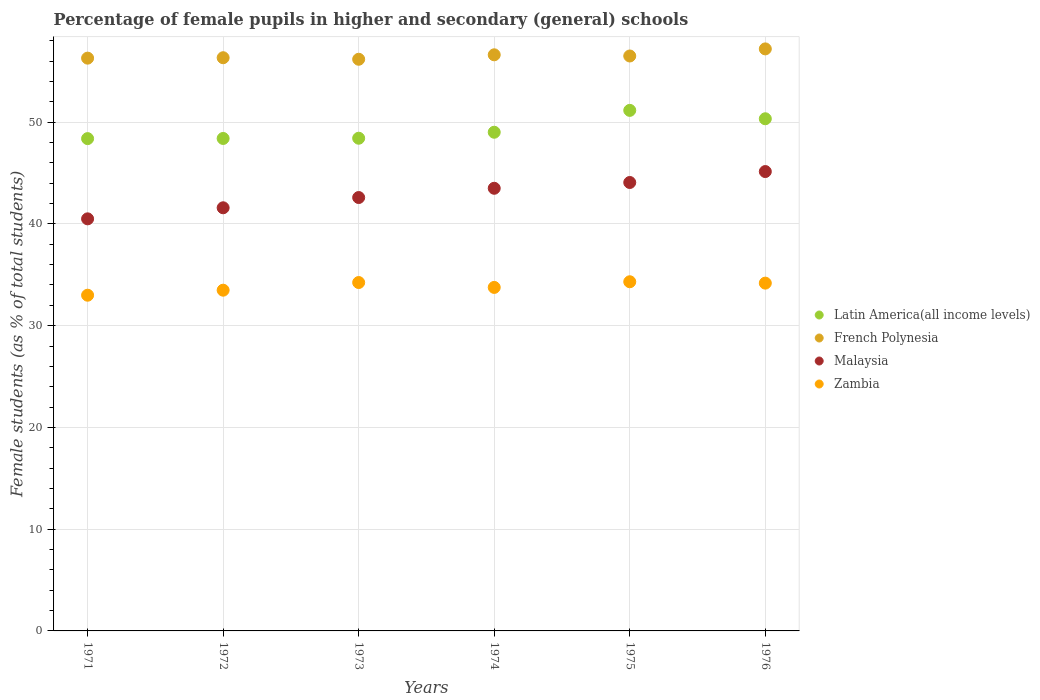Is the number of dotlines equal to the number of legend labels?
Ensure brevity in your answer.  Yes. What is the percentage of female pupils in higher and secondary schools in French Polynesia in 1971?
Your response must be concise. 56.29. Across all years, what is the maximum percentage of female pupils in higher and secondary schools in French Polynesia?
Your response must be concise. 57.2. Across all years, what is the minimum percentage of female pupils in higher and secondary schools in French Polynesia?
Offer a very short reply. 56.18. In which year was the percentage of female pupils in higher and secondary schools in Latin America(all income levels) maximum?
Offer a very short reply. 1975. What is the total percentage of female pupils in higher and secondary schools in French Polynesia in the graph?
Your answer should be compact. 339.11. What is the difference between the percentage of female pupils in higher and secondary schools in Latin America(all income levels) in 1975 and that in 1976?
Give a very brief answer. 0.82. What is the difference between the percentage of female pupils in higher and secondary schools in French Polynesia in 1975 and the percentage of female pupils in higher and secondary schools in Latin America(all income levels) in 1974?
Offer a terse response. 7.49. What is the average percentage of female pupils in higher and secondary schools in French Polynesia per year?
Give a very brief answer. 56.52. In the year 1974, what is the difference between the percentage of female pupils in higher and secondary schools in French Polynesia and percentage of female pupils in higher and secondary schools in Zambia?
Provide a short and direct response. 22.86. What is the ratio of the percentage of female pupils in higher and secondary schools in French Polynesia in 1972 to that in 1973?
Ensure brevity in your answer.  1. Is the percentage of female pupils in higher and secondary schools in Latin America(all income levels) in 1975 less than that in 1976?
Your answer should be very brief. No. What is the difference between the highest and the second highest percentage of female pupils in higher and secondary schools in Zambia?
Offer a terse response. 0.08. What is the difference between the highest and the lowest percentage of female pupils in higher and secondary schools in French Polynesia?
Offer a very short reply. 1.02. In how many years, is the percentage of female pupils in higher and secondary schools in Zambia greater than the average percentage of female pupils in higher and secondary schools in Zambia taken over all years?
Your response must be concise. 3. Is the sum of the percentage of female pupils in higher and secondary schools in Latin America(all income levels) in 1971 and 1975 greater than the maximum percentage of female pupils in higher and secondary schools in Zambia across all years?
Keep it short and to the point. Yes. Is the percentage of female pupils in higher and secondary schools in French Polynesia strictly greater than the percentage of female pupils in higher and secondary schools in Malaysia over the years?
Offer a very short reply. Yes. Is the percentage of female pupils in higher and secondary schools in Latin America(all income levels) strictly less than the percentage of female pupils in higher and secondary schools in Malaysia over the years?
Offer a terse response. No. How many years are there in the graph?
Provide a succinct answer. 6. What is the difference between two consecutive major ticks on the Y-axis?
Give a very brief answer. 10. Does the graph contain any zero values?
Your answer should be compact. No. Does the graph contain grids?
Provide a short and direct response. Yes. Where does the legend appear in the graph?
Your answer should be very brief. Center right. How are the legend labels stacked?
Make the answer very short. Vertical. What is the title of the graph?
Your response must be concise. Percentage of female pupils in higher and secondary (general) schools. What is the label or title of the Y-axis?
Offer a terse response. Female students (as % of total students). What is the Female students (as % of total students) in Latin America(all income levels) in 1971?
Make the answer very short. 48.38. What is the Female students (as % of total students) of French Polynesia in 1971?
Provide a short and direct response. 56.29. What is the Female students (as % of total students) in Malaysia in 1971?
Ensure brevity in your answer.  40.5. What is the Female students (as % of total students) of Zambia in 1971?
Your response must be concise. 32.99. What is the Female students (as % of total students) of Latin America(all income levels) in 1972?
Make the answer very short. 48.4. What is the Female students (as % of total students) in French Polynesia in 1972?
Offer a very short reply. 56.33. What is the Female students (as % of total students) in Malaysia in 1972?
Provide a short and direct response. 41.58. What is the Female students (as % of total students) of Zambia in 1972?
Your response must be concise. 33.48. What is the Female students (as % of total students) of Latin America(all income levels) in 1973?
Make the answer very short. 48.42. What is the Female students (as % of total students) of French Polynesia in 1973?
Give a very brief answer. 56.18. What is the Female students (as % of total students) in Malaysia in 1973?
Offer a terse response. 42.59. What is the Female students (as % of total students) of Zambia in 1973?
Keep it short and to the point. 34.24. What is the Female students (as % of total students) in Latin America(all income levels) in 1974?
Ensure brevity in your answer.  49.01. What is the Female students (as % of total students) of French Polynesia in 1974?
Provide a short and direct response. 56.62. What is the Female students (as % of total students) of Malaysia in 1974?
Provide a succinct answer. 43.5. What is the Female students (as % of total students) in Zambia in 1974?
Keep it short and to the point. 33.76. What is the Female students (as % of total students) of Latin America(all income levels) in 1975?
Provide a succinct answer. 51.16. What is the Female students (as % of total students) in French Polynesia in 1975?
Provide a short and direct response. 56.5. What is the Female students (as % of total students) in Malaysia in 1975?
Provide a succinct answer. 44.07. What is the Female students (as % of total students) in Zambia in 1975?
Keep it short and to the point. 34.31. What is the Female students (as % of total students) of Latin America(all income levels) in 1976?
Provide a short and direct response. 50.33. What is the Female students (as % of total students) in French Polynesia in 1976?
Provide a short and direct response. 57.2. What is the Female students (as % of total students) of Malaysia in 1976?
Provide a succinct answer. 45.14. What is the Female students (as % of total students) of Zambia in 1976?
Offer a very short reply. 34.18. Across all years, what is the maximum Female students (as % of total students) in Latin America(all income levels)?
Provide a succinct answer. 51.16. Across all years, what is the maximum Female students (as % of total students) of French Polynesia?
Your answer should be very brief. 57.2. Across all years, what is the maximum Female students (as % of total students) of Malaysia?
Keep it short and to the point. 45.14. Across all years, what is the maximum Female students (as % of total students) of Zambia?
Ensure brevity in your answer.  34.31. Across all years, what is the minimum Female students (as % of total students) in Latin America(all income levels)?
Your answer should be very brief. 48.38. Across all years, what is the minimum Female students (as % of total students) of French Polynesia?
Provide a succinct answer. 56.18. Across all years, what is the minimum Female students (as % of total students) of Malaysia?
Offer a very short reply. 40.5. Across all years, what is the minimum Female students (as % of total students) of Zambia?
Your answer should be very brief. 32.99. What is the total Female students (as % of total students) in Latin America(all income levels) in the graph?
Keep it short and to the point. 295.69. What is the total Female students (as % of total students) in French Polynesia in the graph?
Offer a very short reply. 339.11. What is the total Female students (as % of total students) of Malaysia in the graph?
Keep it short and to the point. 257.38. What is the total Female students (as % of total students) of Zambia in the graph?
Your answer should be very brief. 202.96. What is the difference between the Female students (as % of total students) in Latin America(all income levels) in 1971 and that in 1972?
Offer a very short reply. -0.01. What is the difference between the Female students (as % of total students) of French Polynesia in 1971 and that in 1972?
Keep it short and to the point. -0.04. What is the difference between the Female students (as % of total students) in Malaysia in 1971 and that in 1972?
Offer a very short reply. -1.09. What is the difference between the Female students (as % of total students) of Zambia in 1971 and that in 1972?
Make the answer very short. -0.49. What is the difference between the Female students (as % of total students) in Latin America(all income levels) in 1971 and that in 1973?
Your answer should be very brief. -0.04. What is the difference between the Female students (as % of total students) of French Polynesia in 1971 and that in 1973?
Provide a short and direct response. 0.11. What is the difference between the Female students (as % of total students) in Malaysia in 1971 and that in 1973?
Keep it short and to the point. -2.09. What is the difference between the Female students (as % of total students) in Zambia in 1971 and that in 1973?
Offer a very short reply. -1.25. What is the difference between the Female students (as % of total students) in Latin America(all income levels) in 1971 and that in 1974?
Provide a short and direct response. -0.63. What is the difference between the Female students (as % of total students) of French Polynesia in 1971 and that in 1974?
Provide a short and direct response. -0.33. What is the difference between the Female students (as % of total students) in Malaysia in 1971 and that in 1974?
Your answer should be very brief. -3. What is the difference between the Female students (as % of total students) of Zambia in 1971 and that in 1974?
Keep it short and to the point. -0.77. What is the difference between the Female students (as % of total students) in Latin America(all income levels) in 1971 and that in 1975?
Give a very brief answer. -2.77. What is the difference between the Female students (as % of total students) of French Polynesia in 1971 and that in 1975?
Give a very brief answer. -0.21. What is the difference between the Female students (as % of total students) in Malaysia in 1971 and that in 1975?
Your answer should be compact. -3.57. What is the difference between the Female students (as % of total students) of Zambia in 1971 and that in 1975?
Make the answer very short. -1.32. What is the difference between the Female students (as % of total students) of Latin America(all income levels) in 1971 and that in 1976?
Offer a terse response. -1.95. What is the difference between the Female students (as % of total students) in French Polynesia in 1971 and that in 1976?
Provide a succinct answer. -0.91. What is the difference between the Female students (as % of total students) in Malaysia in 1971 and that in 1976?
Ensure brevity in your answer.  -4.65. What is the difference between the Female students (as % of total students) of Zambia in 1971 and that in 1976?
Your answer should be very brief. -1.19. What is the difference between the Female students (as % of total students) in Latin America(all income levels) in 1972 and that in 1973?
Make the answer very short. -0.02. What is the difference between the Female students (as % of total students) in French Polynesia in 1972 and that in 1973?
Your answer should be very brief. 0.15. What is the difference between the Female students (as % of total students) in Malaysia in 1972 and that in 1973?
Give a very brief answer. -1.01. What is the difference between the Female students (as % of total students) in Zambia in 1972 and that in 1973?
Provide a succinct answer. -0.75. What is the difference between the Female students (as % of total students) of Latin America(all income levels) in 1972 and that in 1974?
Offer a terse response. -0.61. What is the difference between the Female students (as % of total students) in French Polynesia in 1972 and that in 1974?
Your response must be concise. -0.29. What is the difference between the Female students (as % of total students) in Malaysia in 1972 and that in 1974?
Provide a succinct answer. -1.92. What is the difference between the Female students (as % of total students) of Zambia in 1972 and that in 1974?
Provide a short and direct response. -0.27. What is the difference between the Female students (as % of total students) of Latin America(all income levels) in 1972 and that in 1975?
Make the answer very short. -2.76. What is the difference between the Female students (as % of total students) of French Polynesia in 1972 and that in 1975?
Give a very brief answer. -0.17. What is the difference between the Female students (as % of total students) in Malaysia in 1972 and that in 1975?
Your answer should be very brief. -2.49. What is the difference between the Female students (as % of total students) in Zambia in 1972 and that in 1975?
Give a very brief answer. -0.83. What is the difference between the Female students (as % of total students) of Latin America(all income levels) in 1972 and that in 1976?
Your answer should be very brief. -1.94. What is the difference between the Female students (as % of total students) of French Polynesia in 1972 and that in 1976?
Give a very brief answer. -0.87. What is the difference between the Female students (as % of total students) in Malaysia in 1972 and that in 1976?
Keep it short and to the point. -3.56. What is the difference between the Female students (as % of total students) of Zambia in 1972 and that in 1976?
Offer a very short reply. -0.69. What is the difference between the Female students (as % of total students) of Latin America(all income levels) in 1973 and that in 1974?
Provide a short and direct response. -0.59. What is the difference between the Female students (as % of total students) of French Polynesia in 1973 and that in 1974?
Your answer should be compact. -0.44. What is the difference between the Female students (as % of total students) of Malaysia in 1973 and that in 1974?
Make the answer very short. -0.91. What is the difference between the Female students (as % of total students) in Zambia in 1973 and that in 1974?
Make the answer very short. 0.48. What is the difference between the Female students (as % of total students) in Latin America(all income levels) in 1973 and that in 1975?
Ensure brevity in your answer.  -2.74. What is the difference between the Female students (as % of total students) in French Polynesia in 1973 and that in 1975?
Give a very brief answer. -0.32. What is the difference between the Female students (as % of total students) of Malaysia in 1973 and that in 1975?
Make the answer very short. -1.48. What is the difference between the Female students (as % of total students) of Zambia in 1973 and that in 1975?
Make the answer very short. -0.08. What is the difference between the Female students (as % of total students) of Latin America(all income levels) in 1973 and that in 1976?
Provide a short and direct response. -1.91. What is the difference between the Female students (as % of total students) of French Polynesia in 1973 and that in 1976?
Your answer should be very brief. -1.02. What is the difference between the Female students (as % of total students) in Malaysia in 1973 and that in 1976?
Keep it short and to the point. -2.55. What is the difference between the Female students (as % of total students) of Zambia in 1973 and that in 1976?
Your answer should be very brief. 0.06. What is the difference between the Female students (as % of total students) of Latin America(all income levels) in 1974 and that in 1975?
Provide a succinct answer. -2.15. What is the difference between the Female students (as % of total students) of French Polynesia in 1974 and that in 1975?
Keep it short and to the point. 0.12. What is the difference between the Female students (as % of total students) of Malaysia in 1974 and that in 1975?
Provide a succinct answer. -0.57. What is the difference between the Female students (as % of total students) of Zambia in 1974 and that in 1975?
Keep it short and to the point. -0.56. What is the difference between the Female students (as % of total students) of Latin America(all income levels) in 1974 and that in 1976?
Make the answer very short. -1.32. What is the difference between the Female students (as % of total students) of French Polynesia in 1974 and that in 1976?
Your answer should be very brief. -0.58. What is the difference between the Female students (as % of total students) of Malaysia in 1974 and that in 1976?
Offer a terse response. -1.64. What is the difference between the Female students (as % of total students) in Zambia in 1974 and that in 1976?
Ensure brevity in your answer.  -0.42. What is the difference between the Female students (as % of total students) of Latin America(all income levels) in 1975 and that in 1976?
Give a very brief answer. 0.82. What is the difference between the Female students (as % of total students) of French Polynesia in 1975 and that in 1976?
Offer a very short reply. -0.7. What is the difference between the Female students (as % of total students) of Malaysia in 1975 and that in 1976?
Ensure brevity in your answer.  -1.07. What is the difference between the Female students (as % of total students) of Zambia in 1975 and that in 1976?
Your answer should be very brief. 0.14. What is the difference between the Female students (as % of total students) in Latin America(all income levels) in 1971 and the Female students (as % of total students) in French Polynesia in 1972?
Make the answer very short. -7.95. What is the difference between the Female students (as % of total students) of Latin America(all income levels) in 1971 and the Female students (as % of total students) of Malaysia in 1972?
Keep it short and to the point. 6.8. What is the difference between the Female students (as % of total students) of Latin America(all income levels) in 1971 and the Female students (as % of total students) of Zambia in 1972?
Provide a short and direct response. 14.9. What is the difference between the Female students (as % of total students) of French Polynesia in 1971 and the Female students (as % of total students) of Malaysia in 1972?
Your answer should be very brief. 14.71. What is the difference between the Female students (as % of total students) of French Polynesia in 1971 and the Female students (as % of total students) of Zambia in 1972?
Offer a terse response. 22.8. What is the difference between the Female students (as % of total students) in Malaysia in 1971 and the Female students (as % of total students) in Zambia in 1972?
Give a very brief answer. 7.01. What is the difference between the Female students (as % of total students) in Latin America(all income levels) in 1971 and the Female students (as % of total students) in French Polynesia in 1973?
Ensure brevity in your answer.  -7.8. What is the difference between the Female students (as % of total students) in Latin America(all income levels) in 1971 and the Female students (as % of total students) in Malaysia in 1973?
Offer a very short reply. 5.79. What is the difference between the Female students (as % of total students) in Latin America(all income levels) in 1971 and the Female students (as % of total students) in Zambia in 1973?
Provide a short and direct response. 14.14. What is the difference between the Female students (as % of total students) of French Polynesia in 1971 and the Female students (as % of total students) of Malaysia in 1973?
Offer a very short reply. 13.7. What is the difference between the Female students (as % of total students) of French Polynesia in 1971 and the Female students (as % of total students) of Zambia in 1973?
Your response must be concise. 22.05. What is the difference between the Female students (as % of total students) of Malaysia in 1971 and the Female students (as % of total students) of Zambia in 1973?
Make the answer very short. 6.26. What is the difference between the Female students (as % of total students) in Latin America(all income levels) in 1971 and the Female students (as % of total students) in French Polynesia in 1974?
Provide a succinct answer. -8.24. What is the difference between the Female students (as % of total students) in Latin America(all income levels) in 1971 and the Female students (as % of total students) in Malaysia in 1974?
Keep it short and to the point. 4.88. What is the difference between the Female students (as % of total students) in Latin America(all income levels) in 1971 and the Female students (as % of total students) in Zambia in 1974?
Provide a succinct answer. 14.62. What is the difference between the Female students (as % of total students) in French Polynesia in 1971 and the Female students (as % of total students) in Malaysia in 1974?
Provide a succinct answer. 12.79. What is the difference between the Female students (as % of total students) in French Polynesia in 1971 and the Female students (as % of total students) in Zambia in 1974?
Give a very brief answer. 22.53. What is the difference between the Female students (as % of total students) in Malaysia in 1971 and the Female students (as % of total students) in Zambia in 1974?
Your answer should be very brief. 6.74. What is the difference between the Female students (as % of total students) in Latin America(all income levels) in 1971 and the Female students (as % of total students) in French Polynesia in 1975?
Make the answer very short. -8.12. What is the difference between the Female students (as % of total students) of Latin America(all income levels) in 1971 and the Female students (as % of total students) of Malaysia in 1975?
Your answer should be very brief. 4.31. What is the difference between the Female students (as % of total students) in Latin America(all income levels) in 1971 and the Female students (as % of total students) in Zambia in 1975?
Keep it short and to the point. 14.07. What is the difference between the Female students (as % of total students) of French Polynesia in 1971 and the Female students (as % of total students) of Malaysia in 1975?
Give a very brief answer. 12.22. What is the difference between the Female students (as % of total students) of French Polynesia in 1971 and the Female students (as % of total students) of Zambia in 1975?
Offer a very short reply. 21.97. What is the difference between the Female students (as % of total students) of Malaysia in 1971 and the Female students (as % of total students) of Zambia in 1975?
Provide a short and direct response. 6.18. What is the difference between the Female students (as % of total students) of Latin America(all income levels) in 1971 and the Female students (as % of total students) of French Polynesia in 1976?
Offer a very short reply. -8.82. What is the difference between the Female students (as % of total students) in Latin America(all income levels) in 1971 and the Female students (as % of total students) in Malaysia in 1976?
Offer a very short reply. 3.24. What is the difference between the Female students (as % of total students) in Latin America(all income levels) in 1971 and the Female students (as % of total students) in Zambia in 1976?
Offer a very short reply. 14.2. What is the difference between the Female students (as % of total students) in French Polynesia in 1971 and the Female students (as % of total students) in Malaysia in 1976?
Provide a succinct answer. 11.14. What is the difference between the Female students (as % of total students) of French Polynesia in 1971 and the Female students (as % of total students) of Zambia in 1976?
Offer a very short reply. 22.11. What is the difference between the Female students (as % of total students) of Malaysia in 1971 and the Female students (as % of total students) of Zambia in 1976?
Your answer should be very brief. 6.32. What is the difference between the Female students (as % of total students) in Latin America(all income levels) in 1972 and the Female students (as % of total students) in French Polynesia in 1973?
Provide a succinct answer. -7.78. What is the difference between the Female students (as % of total students) of Latin America(all income levels) in 1972 and the Female students (as % of total students) of Malaysia in 1973?
Offer a very short reply. 5.8. What is the difference between the Female students (as % of total students) in Latin America(all income levels) in 1972 and the Female students (as % of total students) in Zambia in 1973?
Offer a terse response. 14.16. What is the difference between the Female students (as % of total students) in French Polynesia in 1972 and the Female students (as % of total students) in Malaysia in 1973?
Your response must be concise. 13.74. What is the difference between the Female students (as % of total students) in French Polynesia in 1972 and the Female students (as % of total students) in Zambia in 1973?
Give a very brief answer. 22.09. What is the difference between the Female students (as % of total students) in Malaysia in 1972 and the Female students (as % of total students) in Zambia in 1973?
Provide a short and direct response. 7.35. What is the difference between the Female students (as % of total students) in Latin America(all income levels) in 1972 and the Female students (as % of total students) in French Polynesia in 1974?
Offer a very short reply. -8.22. What is the difference between the Female students (as % of total students) of Latin America(all income levels) in 1972 and the Female students (as % of total students) of Malaysia in 1974?
Provide a short and direct response. 4.9. What is the difference between the Female students (as % of total students) of Latin America(all income levels) in 1972 and the Female students (as % of total students) of Zambia in 1974?
Your answer should be compact. 14.64. What is the difference between the Female students (as % of total students) of French Polynesia in 1972 and the Female students (as % of total students) of Malaysia in 1974?
Offer a terse response. 12.83. What is the difference between the Female students (as % of total students) of French Polynesia in 1972 and the Female students (as % of total students) of Zambia in 1974?
Give a very brief answer. 22.57. What is the difference between the Female students (as % of total students) of Malaysia in 1972 and the Female students (as % of total students) of Zambia in 1974?
Keep it short and to the point. 7.83. What is the difference between the Female students (as % of total students) of Latin America(all income levels) in 1972 and the Female students (as % of total students) of French Polynesia in 1975?
Provide a succinct answer. -8.11. What is the difference between the Female students (as % of total students) of Latin America(all income levels) in 1972 and the Female students (as % of total students) of Malaysia in 1975?
Offer a very short reply. 4.33. What is the difference between the Female students (as % of total students) in Latin America(all income levels) in 1972 and the Female students (as % of total students) in Zambia in 1975?
Your answer should be very brief. 14.08. What is the difference between the Female students (as % of total students) in French Polynesia in 1972 and the Female students (as % of total students) in Malaysia in 1975?
Give a very brief answer. 12.26. What is the difference between the Female students (as % of total students) of French Polynesia in 1972 and the Female students (as % of total students) of Zambia in 1975?
Your answer should be compact. 22.02. What is the difference between the Female students (as % of total students) of Malaysia in 1972 and the Female students (as % of total students) of Zambia in 1975?
Provide a short and direct response. 7.27. What is the difference between the Female students (as % of total students) in Latin America(all income levels) in 1972 and the Female students (as % of total students) in French Polynesia in 1976?
Keep it short and to the point. -8.8. What is the difference between the Female students (as % of total students) of Latin America(all income levels) in 1972 and the Female students (as % of total students) of Malaysia in 1976?
Offer a very short reply. 3.25. What is the difference between the Female students (as % of total students) of Latin America(all income levels) in 1972 and the Female students (as % of total students) of Zambia in 1976?
Your answer should be very brief. 14.22. What is the difference between the Female students (as % of total students) of French Polynesia in 1972 and the Female students (as % of total students) of Malaysia in 1976?
Make the answer very short. 11.19. What is the difference between the Female students (as % of total students) of French Polynesia in 1972 and the Female students (as % of total students) of Zambia in 1976?
Ensure brevity in your answer.  22.15. What is the difference between the Female students (as % of total students) of Malaysia in 1972 and the Female students (as % of total students) of Zambia in 1976?
Provide a succinct answer. 7.41. What is the difference between the Female students (as % of total students) in Latin America(all income levels) in 1973 and the Female students (as % of total students) in French Polynesia in 1974?
Your answer should be very brief. -8.2. What is the difference between the Female students (as % of total students) of Latin America(all income levels) in 1973 and the Female students (as % of total students) of Malaysia in 1974?
Provide a succinct answer. 4.92. What is the difference between the Female students (as % of total students) in Latin America(all income levels) in 1973 and the Female students (as % of total students) in Zambia in 1974?
Ensure brevity in your answer.  14.66. What is the difference between the Female students (as % of total students) of French Polynesia in 1973 and the Female students (as % of total students) of Malaysia in 1974?
Your answer should be compact. 12.68. What is the difference between the Female students (as % of total students) in French Polynesia in 1973 and the Female students (as % of total students) in Zambia in 1974?
Offer a terse response. 22.42. What is the difference between the Female students (as % of total students) of Malaysia in 1973 and the Female students (as % of total students) of Zambia in 1974?
Keep it short and to the point. 8.83. What is the difference between the Female students (as % of total students) in Latin America(all income levels) in 1973 and the Female students (as % of total students) in French Polynesia in 1975?
Offer a terse response. -8.08. What is the difference between the Female students (as % of total students) of Latin America(all income levels) in 1973 and the Female students (as % of total students) of Malaysia in 1975?
Your answer should be very brief. 4.35. What is the difference between the Female students (as % of total students) in Latin America(all income levels) in 1973 and the Female students (as % of total students) in Zambia in 1975?
Provide a succinct answer. 14.1. What is the difference between the Female students (as % of total students) of French Polynesia in 1973 and the Female students (as % of total students) of Malaysia in 1975?
Your response must be concise. 12.11. What is the difference between the Female students (as % of total students) in French Polynesia in 1973 and the Female students (as % of total students) in Zambia in 1975?
Your answer should be very brief. 21.86. What is the difference between the Female students (as % of total students) of Malaysia in 1973 and the Female students (as % of total students) of Zambia in 1975?
Provide a succinct answer. 8.28. What is the difference between the Female students (as % of total students) in Latin America(all income levels) in 1973 and the Female students (as % of total students) in French Polynesia in 1976?
Your answer should be very brief. -8.78. What is the difference between the Female students (as % of total students) in Latin America(all income levels) in 1973 and the Female students (as % of total students) in Malaysia in 1976?
Your response must be concise. 3.27. What is the difference between the Female students (as % of total students) of Latin America(all income levels) in 1973 and the Female students (as % of total students) of Zambia in 1976?
Your answer should be compact. 14.24. What is the difference between the Female students (as % of total students) in French Polynesia in 1973 and the Female students (as % of total students) in Malaysia in 1976?
Your answer should be very brief. 11.04. What is the difference between the Female students (as % of total students) in French Polynesia in 1973 and the Female students (as % of total students) in Zambia in 1976?
Give a very brief answer. 22. What is the difference between the Female students (as % of total students) in Malaysia in 1973 and the Female students (as % of total students) in Zambia in 1976?
Your response must be concise. 8.41. What is the difference between the Female students (as % of total students) in Latin America(all income levels) in 1974 and the Female students (as % of total students) in French Polynesia in 1975?
Ensure brevity in your answer.  -7.49. What is the difference between the Female students (as % of total students) in Latin America(all income levels) in 1974 and the Female students (as % of total students) in Malaysia in 1975?
Offer a very short reply. 4.94. What is the difference between the Female students (as % of total students) of Latin America(all income levels) in 1974 and the Female students (as % of total students) of Zambia in 1975?
Make the answer very short. 14.69. What is the difference between the Female students (as % of total students) of French Polynesia in 1974 and the Female students (as % of total students) of Malaysia in 1975?
Your answer should be very brief. 12.55. What is the difference between the Female students (as % of total students) of French Polynesia in 1974 and the Female students (as % of total students) of Zambia in 1975?
Give a very brief answer. 22.3. What is the difference between the Female students (as % of total students) in Malaysia in 1974 and the Female students (as % of total students) in Zambia in 1975?
Your answer should be very brief. 9.19. What is the difference between the Female students (as % of total students) of Latin America(all income levels) in 1974 and the Female students (as % of total students) of French Polynesia in 1976?
Your answer should be compact. -8.19. What is the difference between the Female students (as % of total students) of Latin America(all income levels) in 1974 and the Female students (as % of total students) of Malaysia in 1976?
Offer a terse response. 3.86. What is the difference between the Female students (as % of total students) in Latin America(all income levels) in 1974 and the Female students (as % of total students) in Zambia in 1976?
Provide a succinct answer. 14.83. What is the difference between the Female students (as % of total students) of French Polynesia in 1974 and the Female students (as % of total students) of Malaysia in 1976?
Offer a very short reply. 11.47. What is the difference between the Female students (as % of total students) in French Polynesia in 1974 and the Female students (as % of total students) in Zambia in 1976?
Your answer should be very brief. 22.44. What is the difference between the Female students (as % of total students) of Malaysia in 1974 and the Female students (as % of total students) of Zambia in 1976?
Offer a terse response. 9.32. What is the difference between the Female students (as % of total students) in Latin America(all income levels) in 1975 and the Female students (as % of total students) in French Polynesia in 1976?
Provide a succinct answer. -6.04. What is the difference between the Female students (as % of total students) in Latin America(all income levels) in 1975 and the Female students (as % of total students) in Malaysia in 1976?
Make the answer very short. 6.01. What is the difference between the Female students (as % of total students) in Latin America(all income levels) in 1975 and the Female students (as % of total students) in Zambia in 1976?
Your response must be concise. 16.98. What is the difference between the Female students (as % of total students) of French Polynesia in 1975 and the Female students (as % of total students) of Malaysia in 1976?
Keep it short and to the point. 11.36. What is the difference between the Female students (as % of total students) in French Polynesia in 1975 and the Female students (as % of total students) in Zambia in 1976?
Give a very brief answer. 22.32. What is the difference between the Female students (as % of total students) in Malaysia in 1975 and the Female students (as % of total students) in Zambia in 1976?
Your answer should be very brief. 9.89. What is the average Female students (as % of total students) in Latin America(all income levels) per year?
Offer a very short reply. 49.28. What is the average Female students (as % of total students) of French Polynesia per year?
Keep it short and to the point. 56.52. What is the average Female students (as % of total students) of Malaysia per year?
Your response must be concise. 42.9. What is the average Female students (as % of total students) in Zambia per year?
Your answer should be compact. 33.83. In the year 1971, what is the difference between the Female students (as % of total students) of Latin America(all income levels) and Female students (as % of total students) of French Polynesia?
Provide a succinct answer. -7.91. In the year 1971, what is the difference between the Female students (as % of total students) of Latin America(all income levels) and Female students (as % of total students) of Malaysia?
Your answer should be compact. 7.88. In the year 1971, what is the difference between the Female students (as % of total students) of Latin America(all income levels) and Female students (as % of total students) of Zambia?
Keep it short and to the point. 15.39. In the year 1971, what is the difference between the Female students (as % of total students) of French Polynesia and Female students (as % of total students) of Malaysia?
Provide a short and direct response. 15.79. In the year 1971, what is the difference between the Female students (as % of total students) of French Polynesia and Female students (as % of total students) of Zambia?
Keep it short and to the point. 23.3. In the year 1971, what is the difference between the Female students (as % of total students) of Malaysia and Female students (as % of total students) of Zambia?
Give a very brief answer. 7.5. In the year 1972, what is the difference between the Female students (as % of total students) of Latin America(all income levels) and Female students (as % of total students) of French Polynesia?
Offer a terse response. -7.93. In the year 1972, what is the difference between the Female students (as % of total students) of Latin America(all income levels) and Female students (as % of total students) of Malaysia?
Offer a very short reply. 6.81. In the year 1972, what is the difference between the Female students (as % of total students) in Latin America(all income levels) and Female students (as % of total students) in Zambia?
Offer a very short reply. 14.91. In the year 1972, what is the difference between the Female students (as % of total students) in French Polynesia and Female students (as % of total students) in Malaysia?
Your answer should be compact. 14.75. In the year 1972, what is the difference between the Female students (as % of total students) of French Polynesia and Female students (as % of total students) of Zambia?
Ensure brevity in your answer.  22.84. In the year 1972, what is the difference between the Female students (as % of total students) in Malaysia and Female students (as % of total students) in Zambia?
Ensure brevity in your answer.  8.1. In the year 1973, what is the difference between the Female students (as % of total students) of Latin America(all income levels) and Female students (as % of total students) of French Polynesia?
Offer a terse response. -7.76. In the year 1973, what is the difference between the Female students (as % of total students) in Latin America(all income levels) and Female students (as % of total students) in Malaysia?
Your response must be concise. 5.83. In the year 1973, what is the difference between the Female students (as % of total students) of Latin America(all income levels) and Female students (as % of total students) of Zambia?
Make the answer very short. 14.18. In the year 1973, what is the difference between the Female students (as % of total students) in French Polynesia and Female students (as % of total students) in Malaysia?
Make the answer very short. 13.59. In the year 1973, what is the difference between the Female students (as % of total students) in French Polynesia and Female students (as % of total students) in Zambia?
Provide a succinct answer. 21.94. In the year 1973, what is the difference between the Female students (as % of total students) in Malaysia and Female students (as % of total students) in Zambia?
Give a very brief answer. 8.35. In the year 1974, what is the difference between the Female students (as % of total students) in Latin America(all income levels) and Female students (as % of total students) in French Polynesia?
Offer a terse response. -7.61. In the year 1974, what is the difference between the Female students (as % of total students) in Latin America(all income levels) and Female students (as % of total students) in Malaysia?
Make the answer very short. 5.51. In the year 1974, what is the difference between the Female students (as % of total students) of Latin America(all income levels) and Female students (as % of total students) of Zambia?
Offer a very short reply. 15.25. In the year 1974, what is the difference between the Female students (as % of total students) of French Polynesia and Female students (as % of total students) of Malaysia?
Your answer should be very brief. 13.12. In the year 1974, what is the difference between the Female students (as % of total students) of French Polynesia and Female students (as % of total students) of Zambia?
Offer a terse response. 22.86. In the year 1974, what is the difference between the Female students (as % of total students) in Malaysia and Female students (as % of total students) in Zambia?
Your answer should be compact. 9.74. In the year 1975, what is the difference between the Female students (as % of total students) of Latin America(all income levels) and Female students (as % of total students) of French Polynesia?
Provide a succinct answer. -5.34. In the year 1975, what is the difference between the Female students (as % of total students) in Latin America(all income levels) and Female students (as % of total students) in Malaysia?
Offer a terse response. 7.09. In the year 1975, what is the difference between the Female students (as % of total students) of Latin America(all income levels) and Female students (as % of total students) of Zambia?
Ensure brevity in your answer.  16.84. In the year 1975, what is the difference between the Female students (as % of total students) in French Polynesia and Female students (as % of total students) in Malaysia?
Make the answer very short. 12.43. In the year 1975, what is the difference between the Female students (as % of total students) in French Polynesia and Female students (as % of total students) in Zambia?
Ensure brevity in your answer.  22.19. In the year 1975, what is the difference between the Female students (as % of total students) of Malaysia and Female students (as % of total students) of Zambia?
Your response must be concise. 9.75. In the year 1976, what is the difference between the Female students (as % of total students) of Latin America(all income levels) and Female students (as % of total students) of French Polynesia?
Keep it short and to the point. -6.87. In the year 1976, what is the difference between the Female students (as % of total students) in Latin America(all income levels) and Female students (as % of total students) in Malaysia?
Provide a short and direct response. 5.19. In the year 1976, what is the difference between the Female students (as % of total students) in Latin America(all income levels) and Female students (as % of total students) in Zambia?
Give a very brief answer. 16.15. In the year 1976, what is the difference between the Female students (as % of total students) of French Polynesia and Female students (as % of total students) of Malaysia?
Provide a short and direct response. 12.05. In the year 1976, what is the difference between the Female students (as % of total students) of French Polynesia and Female students (as % of total students) of Zambia?
Provide a succinct answer. 23.02. In the year 1976, what is the difference between the Female students (as % of total students) of Malaysia and Female students (as % of total students) of Zambia?
Offer a very short reply. 10.97. What is the ratio of the Female students (as % of total students) in Latin America(all income levels) in 1971 to that in 1972?
Make the answer very short. 1. What is the ratio of the Female students (as % of total students) of Malaysia in 1971 to that in 1972?
Give a very brief answer. 0.97. What is the ratio of the Female students (as % of total students) of Zambia in 1971 to that in 1972?
Offer a very short reply. 0.99. What is the ratio of the Female students (as % of total students) of French Polynesia in 1971 to that in 1973?
Your answer should be compact. 1. What is the ratio of the Female students (as % of total students) in Malaysia in 1971 to that in 1973?
Keep it short and to the point. 0.95. What is the ratio of the Female students (as % of total students) in Zambia in 1971 to that in 1973?
Provide a succinct answer. 0.96. What is the ratio of the Female students (as % of total students) in Latin America(all income levels) in 1971 to that in 1974?
Give a very brief answer. 0.99. What is the ratio of the Female students (as % of total students) of Malaysia in 1971 to that in 1974?
Your response must be concise. 0.93. What is the ratio of the Female students (as % of total students) of Zambia in 1971 to that in 1974?
Your answer should be very brief. 0.98. What is the ratio of the Female students (as % of total students) of Latin America(all income levels) in 1971 to that in 1975?
Your answer should be very brief. 0.95. What is the ratio of the Female students (as % of total students) in French Polynesia in 1971 to that in 1975?
Your answer should be very brief. 1. What is the ratio of the Female students (as % of total students) of Malaysia in 1971 to that in 1975?
Offer a terse response. 0.92. What is the ratio of the Female students (as % of total students) in Zambia in 1971 to that in 1975?
Give a very brief answer. 0.96. What is the ratio of the Female students (as % of total students) in Latin America(all income levels) in 1971 to that in 1976?
Provide a succinct answer. 0.96. What is the ratio of the Female students (as % of total students) of French Polynesia in 1971 to that in 1976?
Your answer should be compact. 0.98. What is the ratio of the Female students (as % of total students) in Malaysia in 1971 to that in 1976?
Keep it short and to the point. 0.9. What is the ratio of the Female students (as % of total students) of Zambia in 1971 to that in 1976?
Your answer should be compact. 0.97. What is the ratio of the Female students (as % of total students) of French Polynesia in 1972 to that in 1973?
Offer a terse response. 1. What is the ratio of the Female students (as % of total students) in Malaysia in 1972 to that in 1973?
Ensure brevity in your answer.  0.98. What is the ratio of the Female students (as % of total students) of Zambia in 1972 to that in 1973?
Offer a very short reply. 0.98. What is the ratio of the Female students (as % of total students) in Latin America(all income levels) in 1972 to that in 1974?
Your answer should be very brief. 0.99. What is the ratio of the Female students (as % of total students) in French Polynesia in 1972 to that in 1974?
Offer a terse response. 0.99. What is the ratio of the Female students (as % of total students) in Malaysia in 1972 to that in 1974?
Ensure brevity in your answer.  0.96. What is the ratio of the Female students (as % of total students) in Latin America(all income levels) in 1972 to that in 1975?
Offer a very short reply. 0.95. What is the ratio of the Female students (as % of total students) in Malaysia in 1972 to that in 1975?
Offer a very short reply. 0.94. What is the ratio of the Female students (as % of total students) in Zambia in 1972 to that in 1975?
Give a very brief answer. 0.98. What is the ratio of the Female students (as % of total students) in Latin America(all income levels) in 1972 to that in 1976?
Keep it short and to the point. 0.96. What is the ratio of the Female students (as % of total students) of French Polynesia in 1972 to that in 1976?
Make the answer very short. 0.98. What is the ratio of the Female students (as % of total students) in Malaysia in 1972 to that in 1976?
Provide a succinct answer. 0.92. What is the ratio of the Female students (as % of total students) in Zambia in 1972 to that in 1976?
Provide a succinct answer. 0.98. What is the ratio of the Female students (as % of total students) in Latin America(all income levels) in 1973 to that in 1974?
Provide a succinct answer. 0.99. What is the ratio of the Female students (as % of total students) in French Polynesia in 1973 to that in 1974?
Keep it short and to the point. 0.99. What is the ratio of the Female students (as % of total students) in Malaysia in 1973 to that in 1974?
Your answer should be compact. 0.98. What is the ratio of the Female students (as % of total students) of Zambia in 1973 to that in 1974?
Provide a short and direct response. 1.01. What is the ratio of the Female students (as % of total students) in Latin America(all income levels) in 1973 to that in 1975?
Keep it short and to the point. 0.95. What is the ratio of the Female students (as % of total students) of Malaysia in 1973 to that in 1975?
Provide a succinct answer. 0.97. What is the ratio of the Female students (as % of total students) of French Polynesia in 1973 to that in 1976?
Offer a very short reply. 0.98. What is the ratio of the Female students (as % of total students) of Malaysia in 1973 to that in 1976?
Provide a succinct answer. 0.94. What is the ratio of the Female students (as % of total students) of Zambia in 1973 to that in 1976?
Provide a short and direct response. 1. What is the ratio of the Female students (as % of total students) of Latin America(all income levels) in 1974 to that in 1975?
Your response must be concise. 0.96. What is the ratio of the Female students (as % of total students) of French Polynesia in 1974 to that in 1975?
Make the answer very short. 1. What is the ratio of the Female students (as % of total students) of Malaysia in 1974 to that in 1975?
Your response must be concise. 0.99. What is the ratio of the Female students (as % of total students) of Zambia in 1974 to that in 1975?
Your answer should be compact. 0.98. What is the ratio of the Female students (as % of total students) in Latin America(all income levels) in 1974 to that in 1976?
Give a very brief answer. 0.97. What is the ratio of the Female students (as % of total students) in Malaysia in 1974 to that in 1976?
Give a very brief answer. 0.96. What is the ratio of the Female students (as % of total students) in Latin America(all income levels) in 1975 to that in 1976?
Give a very brief answer. 1.02. What is the ratio of the Female students (as % of total students) of French Polynesia in 1975 to that in 1976?
Offer a very short reply. 0.99. What is the ratio of the Female students (as % of total students) of Malaysia in 1975 to that in 1976?
Make the answer very short. 0.98. What is the ratio of the Female students (as % of total students) in Zambia in 1975 to that in 1976?
Offer a terse response. 1. What is the difference between the highest and the second highest Female students (as % of total students) in Latin America(all income levels)?
Offer a terse response. 0.82. What is the difference between the highest and the second highest Female students (as % of total students) of French Polynesia?
Offer a terse response. 0.58. What is the difference between the highest and the second highest Female students (as % of total students) in Malaysia?
Your response must be concise. 1.07. What is the difference between the highest and the second highest Female students (as % of total students) in Zambia?
Provide a short and direct response. 0.08. What is the difference between the highest and the lowest Female students (as % of total students) of Latin America(all income levels)?
Make the answer very short. 2.77. What is the difference between the highest and the lowest Female students (as % of total students) in French Polynesia?
Offer a very short reply. 1.02. What is the difference between the highest and the lowest Female students (as % of total students) of Malaysia?
Provide a succinct answer. 4.65. What is the difference between the highest and the lowest Female students (as % of total students) in Zambia?
Keep it short and to the point. 1.32. 